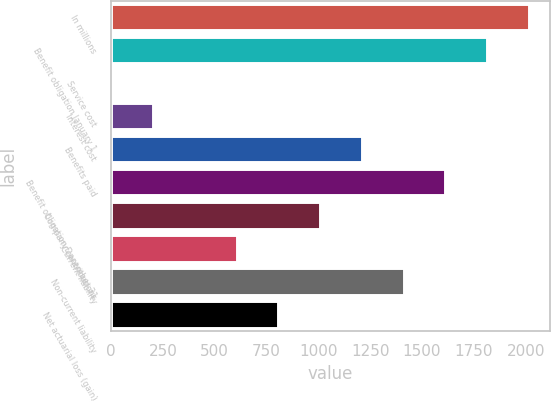Convert chart. <chart><loc_0><loc_0><loc_500><loc_500><bar_chart><fcel>In millions<fcel>Benefit obligation January 1<fcel>Service cost<fcel>Interest cost<fcel>Benefits paid<fcel>Benefit obligation December 31<fcel>Company contributions<fcel>Current liability<fcel>Non-current liability<fcel>Net actuarial loss (gain)<nl><fcel>2015<fcel>1813.6<fcel>1<fcel>202.4<fcel>1209.4<fcel>1612.2<fcel>1008<fcel>605.2<fcel>1410.8<fcel>806.6<nl></chart> 